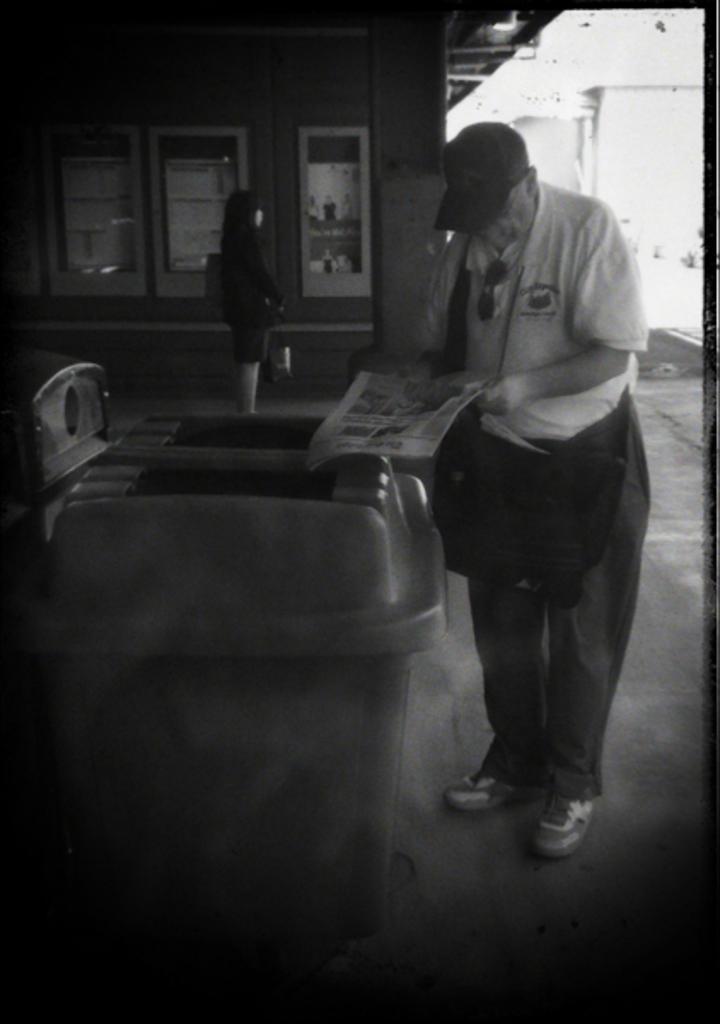Describe this image in one or two sentences. This is a black and white image and here we can see a person wearing glasses, cap and a bag and holding a newspaper. In the background, there is a lady and we can see bins and some boards on the wall. At the bottom, there is a floor. 